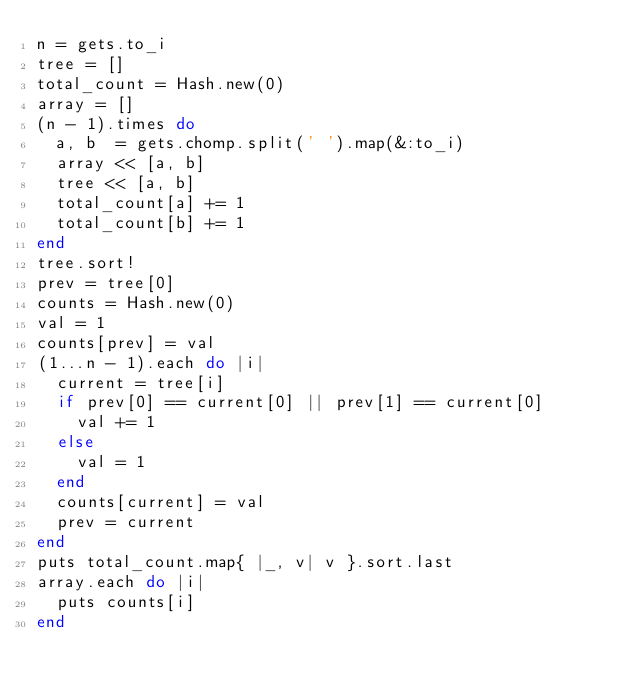Convert code to text. <code><loc_0><loc_0><loc_500><loc_500><_Ruby_>n = gets.to_i
tree = []
total_count = Hash.new(0)
array = []
(n - 1).times do
  a, b  = gets.chomp.split(' ').map(&:to_i)
  array << [a, b]
  tree << [a, b]
  total_count[a] += 1
  total_count[b] += 1
end
tree.sort!
prev = tree[0]
counts = Hash.new(0)
val = 1
counts[prev] = val
(1...n - 1).each do |i|
  current = tree[i]
  if prev[0] == current[0] || prev[1] == current[0]
    val += 1
  else
    val = 1
  end
  counts[current] = val
  prev = current
end
puts total_count.map{ |_, v| v }.sort.last
array.each do |i|
  puts counts[i]
end</code> 